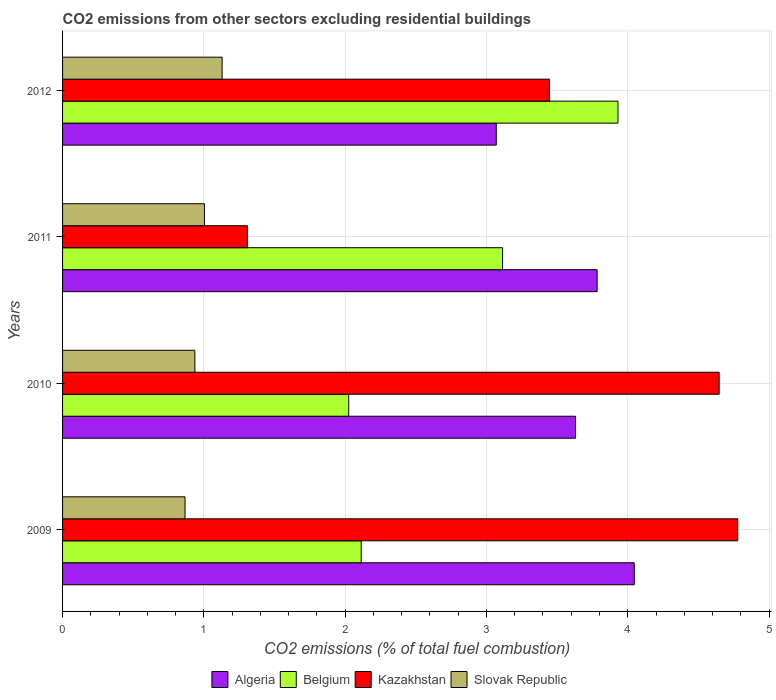What is the label of the 4th group of bars from the top?
Offer a terse response. 2009. What is the total CO2 emitted in Belgium in 2009?
Your response must be concise. 2.11. Across all years, what is the maximum total CO2 emitted in Algeria?
Offer a terse response. 4.05. Across all years, what is the minimum total CO2 emitted in Belgium?
Offer a terse response. 2.03. In which year was the total CO2 emitted in Slovak Republic maximum?
Make the answer very short. 2012. What is the total total CO2 emitted in Belgium in the graph?
Ensure brevity in your answer.  11.18. What is the difference between the total CO2 emitted in Kazakhstan in 2010 and that in 2011?
Your response must be concise. 3.34. What is the difference between the total CO2 emitted in Slovak Republic in 2010 and the total CO2 emitted in Belgium in 2012?
Ensure brevity in your answer.  -2.99. What is the average total CO2 emitted in Kazakhstan per year?
Ensure brevity in your answer.  3.54. In the year 2012, what is the difference between the total CO2 emitted in Belgium and total CO2 emitted in Slovak Republic?
Offer a very short reply. 2.8. In how many years, is the total CO2 emitted in Belgium greater than 2.4 ?
Your response must be concise. 2. What is the ratio of the total CO2 emitted in Algeria in 2009 to that in 2010?
Provide a succinct answer. 1.11. What is the difference between the highest and the second highest total CO2 emitted in Algeria?
Offer a very short reply. 0.26. What is the difference between the highest and the lowest total CO2 emitted in Kazakhstan?
Provide a succinct answer. 3.47. In how many years, is the total CO2 emitted in Algeria greater than the average total CO2 emitted in Algeria taken over all years?
Give a very brief answer. 2. Is the sum of the total CO2 emitted in Algeria in 2010 and 2011 greater than the maximum total CO2 emitted in Slovak Republic across all years?
Offer a terse response. Yes. Is it the case that in every year, the sum of the total CO2 emitted in Algeria and total CO2 emitted in Slovak Republic is greater than the sum of total CO2 emitted in Kazakhstan and total CO2 emitted in Belgium?
Provide a short and direct response. Yes. What does the 3rd bar from the top in 2011 represents?
Make the answer very short. Belgium. What does the 1st bar from the bottom in 2012 represents?
Make the answer very short. Algeria. Is it the case that in every year, the sum of the total CO2 emitted in Algeria and total CO2 emitted in Kazakhstan is greater than the total CO2 emitted in Belgium?
Keep it short and to the point. Yes. Are all the bars in the graph horizontal?
Keep it short and to the point. Yes. Are the values on the major ticks of X-axis written in scientific E-notation?
Keep it short and to the point. No. Does the graph contain any zero values?
Keep it short and to the point. No. Where does the legend appear in the graph?
Ensure brevity in your answer.  Bottom center. How many legend labels are there?
Offer a terse response. 4. How are the legend labels stacked?
Offer a very short reply. Horizontal. What is the title of the graph?
Keep it short and to the point. CO2 emissions from other sectors excluding residential buildings. What is the label or title of the X-axis?
Offer a very short reply. CO2 emissions (% of total fuel combustion). What is the label or title of the Y-axis?
Your response must be concise. Years. What is the CO2 emissions (% of total fuel combustion) of Algeria in 2009?
Make the answer very short. 4.05. What is the CO2 emissions (% of total fuel combustion) in Belgium in 2009?
Your response must be concise. 2.11. What is the CO2 emissions (% of total fuel combustion) in Kazakhstan in 2009?
Give a very brief answer. 4.78. What is the CO2 emissions (% of total fuel combustion) of Slovak Republic in 2009?
Keep it short and to the point. 0.87. What is the CO2 emissions (% of total fuel combustion) in Algeria in 2010?
Your answer should be compact. 3.63. What is the CO2 emissions (% of total fuel combustion) of Belgium in 2010?
Keep it short and to the point. 2.03. What is the CO2 emissions (% of total fuel combustion) in Kazakhstan in 2010?
Keep it short and to the point. 4.65. What is the CO2 emissions (% of total fuel combustion) of Slovak Republic in 2010?
Give a very brief answer. 0.94. What is the CO2 emissions (% of total fuel combustion) of Algeria in 2011?
Your response must be concise. 3.78. What is the CO2 emissions (% of total fuel combustion) of Belgium in 2011?
Your answer should be compact. 3.11. What is the CO2 emissions (% of total fuel combustion) in Kazakhstan in 2011?
Ensure brevity in your answer.  1.31. What is the CO2 emissions (% of total fuel combustion) of Slovak Republic in 2011?
Your answer should be very brief. 1. What is the CO2 emissions (% of total fuel combustion) in Algeria in 2012?
Keep it short and to the point. 3.07. What is the CO2 emissions (% of total fuel combustion) of Belgium in 2012?
Provide a succinct answer. 3.93. What is the CO2 emissions (% of total fuel combustion) in Kazakhstan in 2012?
Offer a terse response. 3.45. What is the CO2 emissions (% of total fuel combustion) in Slovak Republic in 2012?
Make the answer very short. 1.13. Across all years, what is the maximum CO2 emissions (% of total fuel combustion) of Algeria?
Offer a terse response. 4.05. Across all years, what is the maximum CO2 emissions (% of total fuel combustion) of Belgium?
Provide a short and direct response. 3.93. Across all years, what is the maximum CO2 emissions (% of total fuel combustion) of Kazakhstan?
Provide a short and direct response. 4.78. Across all years, what is the maximum CO2 emissions (% of total fuel combustion) in Slovak Republic?
Give a very brief answer. 1.13. Across all years, what is the minimum CO2 emissions (% of total fuel combustion) of Algeria?
Your answer should be compact. 3.07. Across all years, what is the minimum CO2 emissions (% of total fuel combustion) in Belgium?
Your answer should be very brief. 2.03. Across all years, what is the minimum CO2 emissions (% of total fuel combustion) of Kazakhstan?
Provide a succinct answer. 1.31. Across all years, what is the minimum CO2 emissions (% of total fuel combustion) of Slovak Republic?
Ensure brevity in your answer.  0.87. What is the total CO2 emissions (% of total fuel combustion) in Algeria in the graph?
Keep it short and to the point. 14.53. What is the total CO2 emissions (% of total fuel combustion) in Belgium in the graph?
Provide a short and direct response. 11.18. What is the total CO2 emissions (% of total fuel combustion) in Kazakhstan in the graph?
Keep it short and to the point. 14.18. What is the total CO2 emissions (% of total fuel combustion) in Slovak Republic in the graph?
Provide a short and direct response. 3.94. What is the difference between the CO2 emissions (% of total fuel combustion) of Algeria in 2009 and that in 2010?
Your answer should be very brief. 0.42. What is the difference between the CO2 emissions (% of total fuel combustion) of Belgium in 2009 and that in 2010?
Offer a very short reply. 0.09. What is the difference between the CO2 emissions (% of total fuel combustion) in Kazakhstan in 2009 and that in 2010?
Give a very brief answer. 0.13. What is the difference between the CO2 emissions (% of total fuel combustion) in Slovak Republic in 2009 and that in 2010?
Your answer should be compact. -0.07. What is the difference between the CO2 emissions (% of total fuel combustion) of Algeria in 2009 and that in 2011?
Keep it short and to the point. 0.26. What is the difference between the CO2 emissions (% of total fuel combustion) of Belgium in 2009 and that in 2011?
Your answer should be compact. -1. What is the difference between the CO2 emissions (% of total fuel combustion) in Kazakhstan in 2009 and that in 2011?
Give a very brief answer. 3.47. What is the difference between the CO2 emissions (% of total fuel combustion) of Slovak Republic in 2009 and that in 2011?
Provide a short and direct response. -0.14. What is the difference between the CO2 emissions (% of total fuel combustion) in Algeria in 2009 and that in 2012?
Offer a very short reply. 0.98. What is the difference between the CO2 emissions (% of total fuel combustion) in Belgium in 2009 and that in 2012?
Give a very brief answer. -1.82. What is the difference between the CO2 emissions (% of total fuel combustion) in Kazakhstan in 2009 and that in 2012?
Ensure brevity in your answer.  1.33. What is the difference between the CO2 emissions (% of total fuel combustion) of Slovak Republic in 2009 and that in 2012?
Provide a short and direct response. -0.26. What is the difference between the CO2 emissions (% of total fuel combustion) in Algeria in 2010 and that in 2011?
Ensure brevity in your answer.  -0.15. What is the difference between the CO2 emissions (% of total fuel combustion) in Belgium in 2010 and that in 2011?
Give a very brief answer. -1.09. What is the difference between the CO2 emissions (% of total fuel combustion) of Kazakhstan in 2010 and that in 2011?
Your response must be concise. 3.34. What is the difference between the CO2 emissions (% of total fuel combustion) in Slovak Republic in 2010 and that in 2011?
Make the answer very short. -0.07. What is the difference between the CO2 emissions (% of total fuel combustion) in Algeria in 2010 and that in 2012?
Offer a terse response. 0.56. What is the difference between the CO2 emissions (% of total fuel combustion) in Belgium in 2010 and that in 2012?
Provide a succinct answer. -1.91. What is the difference between the CO2 emissions (% of total fuel combustion) in Kazakhstan in 2010 and that in 2012?
Your answer should be compact. 1.2. What is the difference between the CO2 emissions (% of total fuel combustion) of Slovak Republic in 2010 and that in 2012?
Offer a terse response. -0.19. What is the difference between the CO2 emissions (% of total fuel combustion) in Algeria in 2011 and that in 2012?
Give a very brief answer. 0.71. What is the difference between the CO2 emissions (% of total fuel combustion) of Belgium in 2011 and that in 2012?
Ensure brevity in your answer.  -0.82. What is the difference between the CO2 emissions (% of total fuel combustion) in Kazakhstan in 2011 and that in 2012?
Your answer should be compact. -2.14. What is the difference between the CO2 emissions (% of total fuel combustion) of Slovak Republic in 2011 and that in 2012?
Make the answer very short. -0.13. What is the difference between the CO2 emissions (% of total fuel combustion) of Algeria in 2009 and the CO2 emissions (% of total fuel combustion) of Belgium in 2010?
Your response must be concise. 2.02. What is the difference between the CO2 emissions (% of total fuel combustion) in Algeria in 2009 and the CO2 emissions (% of total fuel combustion) in Kazakhstan in 2010?
Provide a succinct answer. -0.6. What is the difference between the CO2 emissions (% of total fuel combustion) of Algeria in 2009 and the CO2 emissions (% of total fuel combustion) of Slovak Republic in 2010?
Provide a short and direct response. 3.11. What is the difference between the CO2 emissions (% of total fuel combustion) in Belgium in 2009 and the CO2 emissions (% of total fuel combustion) in Kazakhstan in 2010?
Give a very brief answer. -2.53. What is the difference between the CO2 emissions (% of total fuel combustion) of Belgium in 2009 and the CO2 emissions (% of total fuel combustion) of Slovak Republic in 2010?
Keep it short and to the point. 1.18. What is the difference between the CO2 emissions (% of total fuel combustion) of Kazakhstan in 2009 and the CO2 emissions (% of total fuel combustion) of Slovak Republic in 2010?
Give a very brief answer. 3.84. What is the difference between the CO2 emissions (% of total fuel combustion) in Algeria in 2009 and the CO2 emissions (% of total fuel combustion) in Belgium in 2011?
Provide a short and direct response. 0.93. What is the difference between the CO2 emissions (% of total fuel combustion) of Algeria in 2009 and the CO2 emissions (% of total fuel combustion) of Kazakhstan in 2011?
Offer a terse response. 2.74. What is the difference between the CO2 emissions (% of total fuel combustion) of Algeria in 2009 and the CO2 emissions (% of total fuel combustion) of Slovak Republic in 2011?
Offer a terse response. 3.04. What is the difference between the CO2 emissions (% of total fuel combustion) of Belgium in 2009 and the CO2 emissions (% of total fuel combustion) of Kazakhstan in 2011?
Your answer should be compact. 0.81. What is the difference between the CO2 emissions (% of total fuel combustion) in Belgium in 2009 and the CO2 emissions (% of total fuel combustion) in Slovak Republic in 2011?
Offer a terse response. 1.11. What is the difference between the CO2 emissions (% of total fuel combustion) in Kazakhstan in 2009 and the CO2 emissions (% of total fuel combustion) in Slovak Republic in 2011?
Your response must be concise. 3.77. What is the difference between the CO2 emissions (% of total fuel combustion) in Algeria in 2009 and the CO2 emissions (% of total fuel combustion) in Belgium in 2012?
Provide a short and direct response. 0.12. What is the difference between the CO2 emissions (% of total fuel combustion) in Algeria in 2009 and the CO2 emissions (% of total fuel combustion) in Kazakhstan in 2012?
Offer a very short reply. 0.6. What is the difference between the CO2 emissions (% of total fuel combustion) in Algeria in 2009 and the CO2 emissions (% of total fuel combustion) in Slovak Republic in 2012?
Offer a very short reply. 2.92. What is the difference between the CO2 emissions (% of total fuel combustion) in Belgium in 2009 and the CO2 emissions (% of total fuel combustion) in Kazakhstan in 2012?
Offer a very short reply. -1.33. What is the difference between the CO2 emissions (% of total fuel combustion) of Belgium in 2009 and the CO2 emissions (% of total fuel combustion) of Slovak Republic in 2012?
Make the answer very short. 0.98. What is the difference between the CO2 emissions (% of total fuel combustion) of Kazakhstan in 2009 and the CO2 emissions (% of total fuel combustion) of Slovak Republic in 2012?
Make the answer very short. 3.65. What is the difference between the CO2 emissions (% of total fuel combustion) of Algeria in 2010 and the CO2 emissions (% of total fuel combustion) of Belgium in 2011?
Keep it short and to the point. 0.52. What is the difference between the CO2 emissions (% of total fuel combustion) of Algeria in 2010 and the CO2 emissions (% of total fuel combustion) of Kazakhstan in 2011?
Your response must be concise. 2.32. What is the difference between the CO2 emissions (% of total fuel combustion) of Algeria in 2010 and the CO2 emissions (% of total fuel combustion) of Slovak Republic in 2011?
Make the answer very short. 2.63. What is the difference between the CO2 emissions (% of total fuel combustion) of Belgium in 2010 and the CO2 emissions (% of total fuel combustion) of Kazakhstan in 2011?
Keep it short and to the point. 0.72. What is the difference between the CO2 emissions (% of total fuel combustion) in Belgium in 2010 and the CO2 emissions (% of total fuel combustion) in Slovak Republic in 2011?
Ensure brevity in your answer.  1.02. What is the difference between the CO2 emissions (% of total fuel combustion) of Kazakhstan in 2010 and the CO2 emissions (% of total fuel combustion) of Slovak Republic in 2011?
Provide a succinct answer. 3.64. What is the difference between the CO2 emissions (% of total fuel combustion) in Algeria in 2010 and the CO2 emissions (% of total fuel combustion) in Belgium in 2012?
Give a very brief answer. -0.3. What is the difference between the CO2 emissions (% of total fuel combustion) in Algeria in 2010 and the CO2 emissions (% of total fuel combustion) in Kazakhstan in 2012?
Keep it short and to the point. 0.18. What is the difference between the CO2 emissions (% of total fuel combustion) in Algeria in 2010 and the CO2 emissions (% of total fuel combustion) in Slovak Republic in 2012?
Offer a terse response. 2.5. What is the difference between the CO2 emissions (% of total fuel combustion) in Belgium in 2010 and the CO2 emissions (% of total fuel combustion) in Kazakhstan in 2012?
Provide a short and direct response. -1.42. What is the difference between the CO2 emissions (% of total fuel combustion) of Belgium in 2010 and the CO2 emissions (% of total fuel combustion) of Slovak Republic in 2012?
Your response must be concise. 0.9. What is the difference between the CO2 emissions (% of total fuel combustion) in Kazakhstan in 2010 and the CO2 emissions (% of total fuel combustion) in Slovak Republic in 2012?
Offer a very short reply. 3.52. What is the difference between the CO2 emissions (% of total fuel combustion) in Algeria in 2011 and the CO2 emissions (% of total fuel combustion) in Belgium in 2012?
Your answer should be very brief. -0.15. What is the difference between the CO2 emissions (% of total fuel combustion) of Algeria in 2011 and the CO2 emissions (% of total fuel combustion) of Kazakhstan in 2012?
Your answer should be compact. 0.34. What is the difference between the CO2 emissions (% of total fuel combustion) of Algeria in 2011 and the CO2 emissions (% of total fuel combustion) of Slovak Republic in 2012?
Your response must be concise. 2.65. What is the difference between the CO2 emissions (% of total fuel combustion) of Belgium in 2011 and the CO2 emissions (% of total fuel combustion) of Kazakhstan in 2012?
Offer a very short reply. -0.33. What is the difference between the CO2 emissions (% of total fuel combustion) of Belgium in 2011 and the CO2 emissions (% of total fuel combustion) of Slovak Republic in 2012?
Ensure brevity in your answer.  1.99. What is the difference between the CO2 emissions (% of total fuel combustion) in Kazakhstan in 2011 and the CO2 emissions (% of total fuel combustion) in Slovak Republic in 2012?
Provide a short and direct response. 0.18. What is the average CO2 emissions (% of total fuel combustion) of Algeria per year?
Your answer should be compact. 3.63. What is the average CO2 emissions (% of total fuel combustion) of Belgium per year?
Offer a terse response. 2.8. What is the average CO2 emissions (% of total fuel combustion) in Kazakhstan per year?
Make the answer very short. 3.54. What is the average CO2 emissions (% of total fuel combustion) of Slovak Republic per year?
Your answer should be compact. 0.98. In the year 2009, what is the difference between the CO2 emissions (% of total fuel combustion) in Algeria and CO2 emissions (% of total fuel combustion) in Belgium?
Provide a short and direct response. 1.93. In the year 2009, what is the difference between the CO2 emissions (% of total fuel combustion) in Algeria and CO2 emissions (% of total fuel combustion) in Kazakhstan?
Your response must be concise. -0.73. In the year 2009, what is the difference between the CO2 emissions (% of total fuel combustion) in Algeria and CO2 emissions (% of total fuel combustion) in Slovak Republic?
Provide a succinct answer. 3.18. In the year 2009, what is the difference between the CO2 emissions (% of total fuel combustion) in Belgium and CO2 emissions (% of total fuel combustion) in Kazakhstan?
Give a very brief answer. -2.66. In the year 2009, what is the difference between the CO2 emissions (% of total fuel combustion) in Belgium and CO2 emissions (% of total fuel combustion) in Slovak Republic?
Make the answer very short. 1.25. In the year 2009, what is the difference between the CO2 emissions (% of total fuel combustion) of Kazakhstan and CO2 emissions (% of total fuel combustion) of Slovak Republic?
Your answer should be very brief. 3.91. In the year 2010, what is the difference between the CO2 emissions (% of total fuel combustion) in Algeria and CO2 emissions (% of total fuel combustion) in Belgium?
Your answer should be compact. 1.61. In the year 2010, what is the difference between the CO2 emissions (% of total fuel combustion) of Algeria and CO2 emissions (% of total fuel combustion) of Kazakhstan?
Make the answer very short. -1.02. In the year 2010, what is the difference between the CO2 emissions (% of total fuel combustion) in Algeria and CO2 emissions (% of total fuel combustion) in Slovak Republic?
Make the answer very short. 2.69. In the year 2010, what is the difference between the CO2 emissions (% of total fuel combustion) of Belgium and CO2 emissions (% of total fuel combustion) of Kazakhstan?
Offer a very short reply. -2.62. In the year 2010, what is the difference between the CO2 emissions (% of total fuel combustion) of Belgium and CO2 emissions (% of total fuel combustion) of Slovak Republic?
Your answer should be compact. 1.09. In the year 2010, what is the difference between the CO2 emissions (% of total fuel combustion) in Kazakhstan and CO2 emissions (% of total fuel combustion) in Slovak Republic?
Ensure brevity in your answer.  3.71. In the year 2011, what is the difference between the CO2 emissions (% of total fuel combustion) of Algeria and CO2 emissions (% of total fuel combustion) of Belgium?
Your answer should be very brief. 0.67. In the year 2011, what is the difference between the CO2 emissions (% of total fuel combustion) in Algeria and CO2 emissions (% of total fuel combustion) in Kazakhstan?
Your answer should be very brief. 2.48. In the year 2011, what is the difference between the CO2 emissions (% of total fuel combustion) in Algeria and CO2 emissions (% of total fuel combustion) in Slovak Republic?
Give a very brief answer. 2.78. In the year 2011, what is the difference between the CO2 emissions (% of total fuel combustion) of Belgium and CO2 emissions (% of total fuel combustion) of Kazakhstan?
Offer a very short reply. 1.81. In the year 2011, what is the difference between the CO2 emissions (% of total fuel combustion) in Belgium and CO2 emissions (% of total fuel combustion) in Slovak Republic?
Your response must be concise. 2.11. In the year 2011, what is the difference between the CO2 emissions (% of total fuel combustion) in Kazakhstan and CO2 emissions (% of total fuel combustion) in Slovak Republic?
Ensure brevity in your answer.  0.3. In the year 2012, what is the difference between the CO2 emissions (% of total fuel combustion) of Algeria and CO2 emissions (% of total fuel combustion) of Belgium?
Your answer should be very brief. -0.86. In the year 2012, what is the difference between the CO2 emissions (% of total fuel combustion) of Algeria and CO2 emissions (% of total fuel combustion) of Kazakhstan?
Give a very brief answer. -0.38. In the year 2012, what is the difference between the CO2 emissions (% of total fuel combustion) in Algeria and CO2 emissions (% of total fuel combustion) in Slovak Republic?
Provide a short and direct response. 1.94. In the year 2012, what is the difference between the CO2 emissions (% of total fuel combustion) of Belgium and CO2 emissions (% of total fuel combustion) of Kazakhstan?
Offer a terse response. 0.48. In the year 2012, what is the difference between the CO2 emissions (% of total fuel combustion) of Belgium and CO2 emissions (% of total fuel combustion) of Slovak Republic?
Give a very brief answer. 2.8. In the year 2012, what is the difference between the CO2 emissions (% of total fuel combustion) in Kazakhstan and CO2 emissions (% of total fuel combustion) in Slovak Republic?
Offer a very short reply. 2.32. What is the ratio of the CO2 emissions (% of total fuel combustion) in Algeria in 2009 to that in 2010?
Offer a terse response. 1.11. What is the ratio of the CO2 emissions (% of total fuel combustion) in Belgium in 2009 to that in 2010?
Ensure brevity in your answer.  1.04. What is the ratio of the CO2 emissions (% of total fuel combustion) in Kazakhstan in 2009 to that in 2010?
Your answer should be compact. 1.03. What is the ratio of the CO2 emissions (% of total fuel combustion) of Slovak Republic in 2009 to that in 2010?
Your response must be concise. 0.93. What is the ratio of the CO2 emissions (% of total fuel combustion) of Algeria in 2009 to that in 2011?
Your answer should be compact. 1.07. What is the ratio of the CO2 emissions (% of total fuel combustion) of Belgium in 2009 to that in 2011?
Your answer should be compact. 0.68. What is the ratio of the CO2 emissions (% of total fuel combustion) in Kazakhstan in 2009 to that in 2011?
Provide a succinct answer. 3.65. What is the ratio of the CO2 emissions (% of total fuel combustion) of Slovak Republic in 2009 to that in 2011?
Offer a terse response. 0.86. What is the ratio of the CO2 emissions (% of total fuel combustion) in Algeria in 2009 to that in 2012?
Your answer should be compact. 1.32. What is the ratio of the CO2 emissions (% of total fuel combustion) in Belgium in 2009 to that in 2012?
Keep it short and to the point. 0.54. What is the ratio of the CO2 emissions (% of total fuel combustion) of Kazakhstan in 2009 to that in 2012?
Make the answer very short. 1.39. What is the ratio of the CO2 emissions (% of total fuel combustion) of Slovak Republic in 2009 to that in 2012?
Provide a short and direct response. 0.77. What is the ratio of the CO2 emissions (% of total fuel combustion) of Algeria in 2010 to that in 2011?
Offer a terse response. 0.96. What is the ratio of the CO2 emissions (% of total fuel combustion) in Belgium in 2010 to that in 2011?
Your answer should be very brief. 0.65. What is the ratio of the CO2 emissions (% of total fuel combustion) in Kazakhstan in 2010 to that in 2011?
Give a very brief answer. 3.55. What is the ratio of the CO2 emissions (% of total fuel combustion) of Slovak Republic in 2010 to that in 2011?
Ensure brevity in your answer.  0.93. What is the ratio of the CO2 emissions (% of total fuel combustion) of Algeria in 2010 to that in 2012?
Your answer should be compact. 1.18. What is the ratio of the CO2 emissions (% of total fuel combustion) in Belgium in 2010 to that in 2012?
Give a very brief answer. 0.52. What is the ratio of the CO2 emissions (% of total fuel combustion) in Kazakhstan in 2010 to that in 2012?
Your response must be concise. 1.35. What is the ratio of the CO2 emissions (% of total fuel combustion) in Slovak Republic in 2010 to that in 2012?
Provide a succinct answer. 0.83. What is the ratio of the CO2 emissions (% of total fuel combustion) of Algeria in 2011 to that in 2012?
Your response must be concise. 1.23. What is the ratio of the CO2 emissions (% of total fuel combustion) of Belgium in 2011 to that in 2012?
Your answer should be compact. 0.79. What is the ratio of the CO2 emissions (% of total fuel combustion) of Kazakhstan in 2011 to that in 2012?
Ensure brevity in your answer.  0.38. What is the ratio of the CO2 emissions (% of total fuel combustion) in Slovak Republic in 2011 to that in 2012?
Keep it short and to the point. 0.89. What is the difference between the highest and the second highest CO2 emissions (% of total fuel combustion) of Algeria?
Your response must be concise. 0.26. What is the difference between the highest and the second highest CO2 emissions (% of total fuel combustion) of Belgium?
Make the answer very short. 0.82. What is the difference between the highest and the second highest CO2 emissions (% of total fuel combustion) in Kazakhstan?
Provide a short and direct response. 0.13. What is the difference between the highest and the second highest CO2 emissions (% of total fuel combustion) of Slovak Republic?
Your answer should be compact. 0.13. What is the difference between the highest and the lowest CO2 emissions (% of total fuel combustion) of Algeria?
Keep it short and to the point. 0.98. What is the difference between the highest and the lowest CO2 emissions (% of total fuel combustion) in Belgium?
Give a very brief answer. 1.91. What is the difference between the highest and the lowest CO2 emissions (% of total fuel combustion) of Kazakhstan?
Your answer should be very brief. 3.47. What is the difference between the highest and the lowest CO2 emissions (% of total fuel combustion) of Slovak Republic?
Your answer should be very brief. 0.26. 